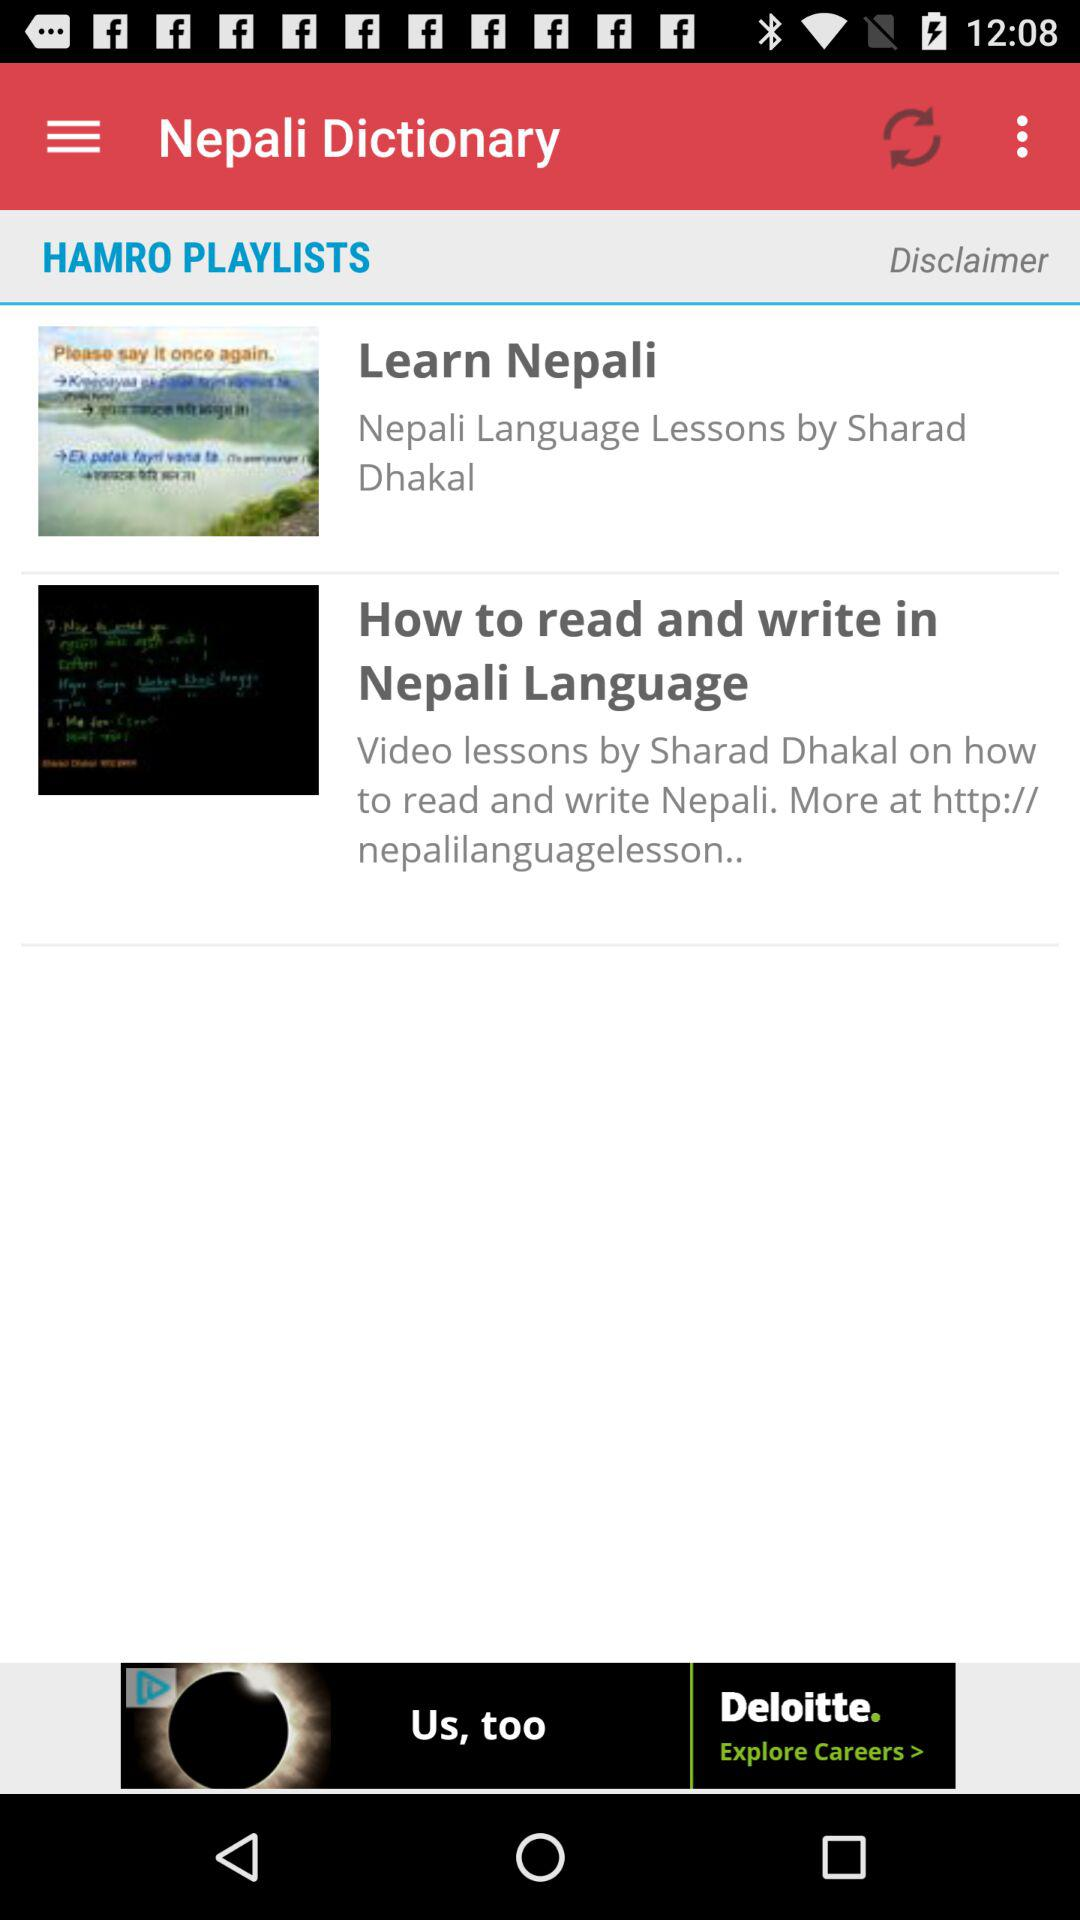Who is the instructor of Nepali language? The instructor of Nepali language is Sharad Dhakal. 